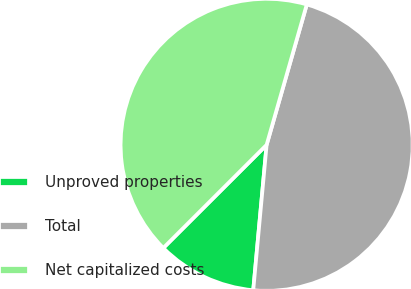Convert chart to OTSL. <chart><loc_0><loc_0><loc_500><loc_500><pie_chart><fcel>Unproved properties<fcel>Total<fcel>Net capitalized costs<nl><fcel>11.05%<fcel>47.03%<fcel>41.93%<nl></chart> 